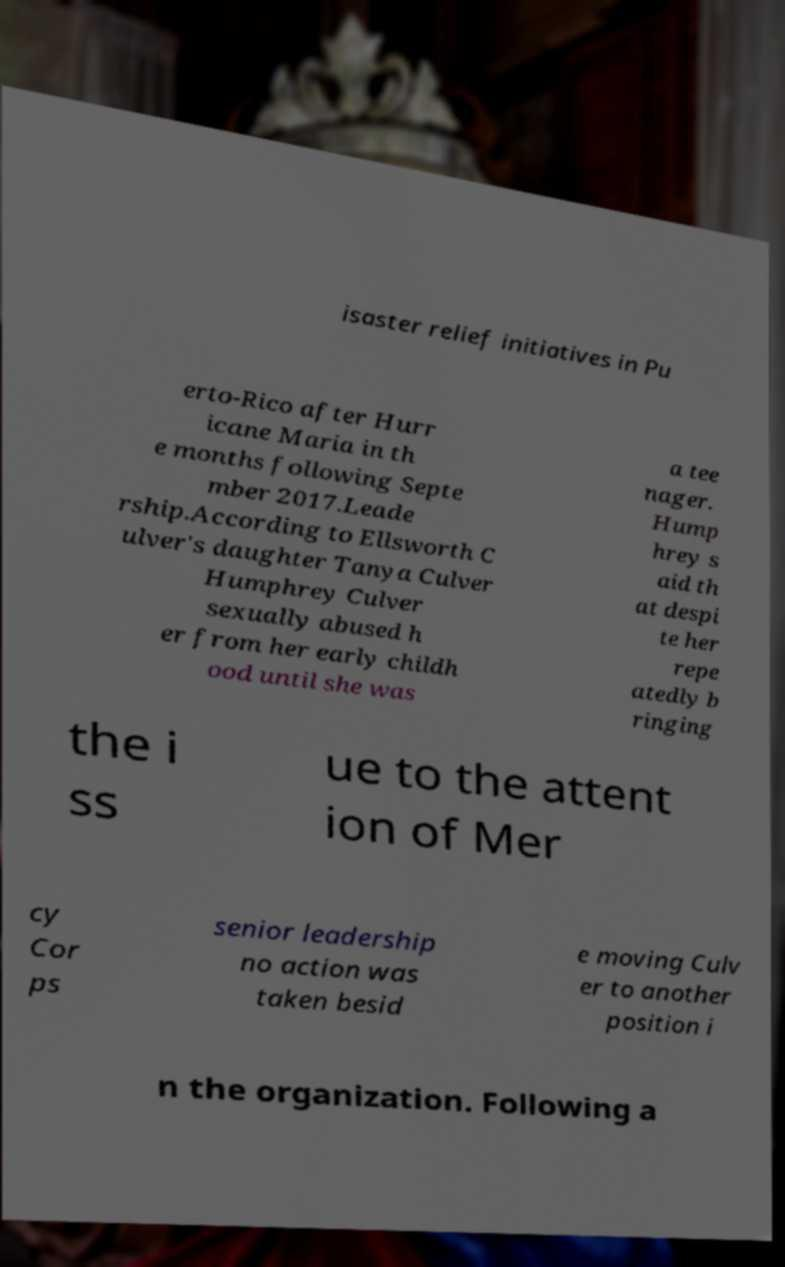For documentation purposes, I need the text within this image transcribed. Could you provide that? isaster relief initiatives in Pu erto-Rico after Hurr icane Maria in th e months following Septe mber 2017.Leade rship.According to Ellsworth C ulver's daughter Tanya Culver Humphrey Culver sexually abused h er from her early childh ood until she was a tee nager. Hump hrey s aid th at despi te her repe atedly b ringing the i ss ue to the attent ion of Mer cy Cor ps senior leadership no action was taken besid e moving Culv er to another position i n the organization. Following a 